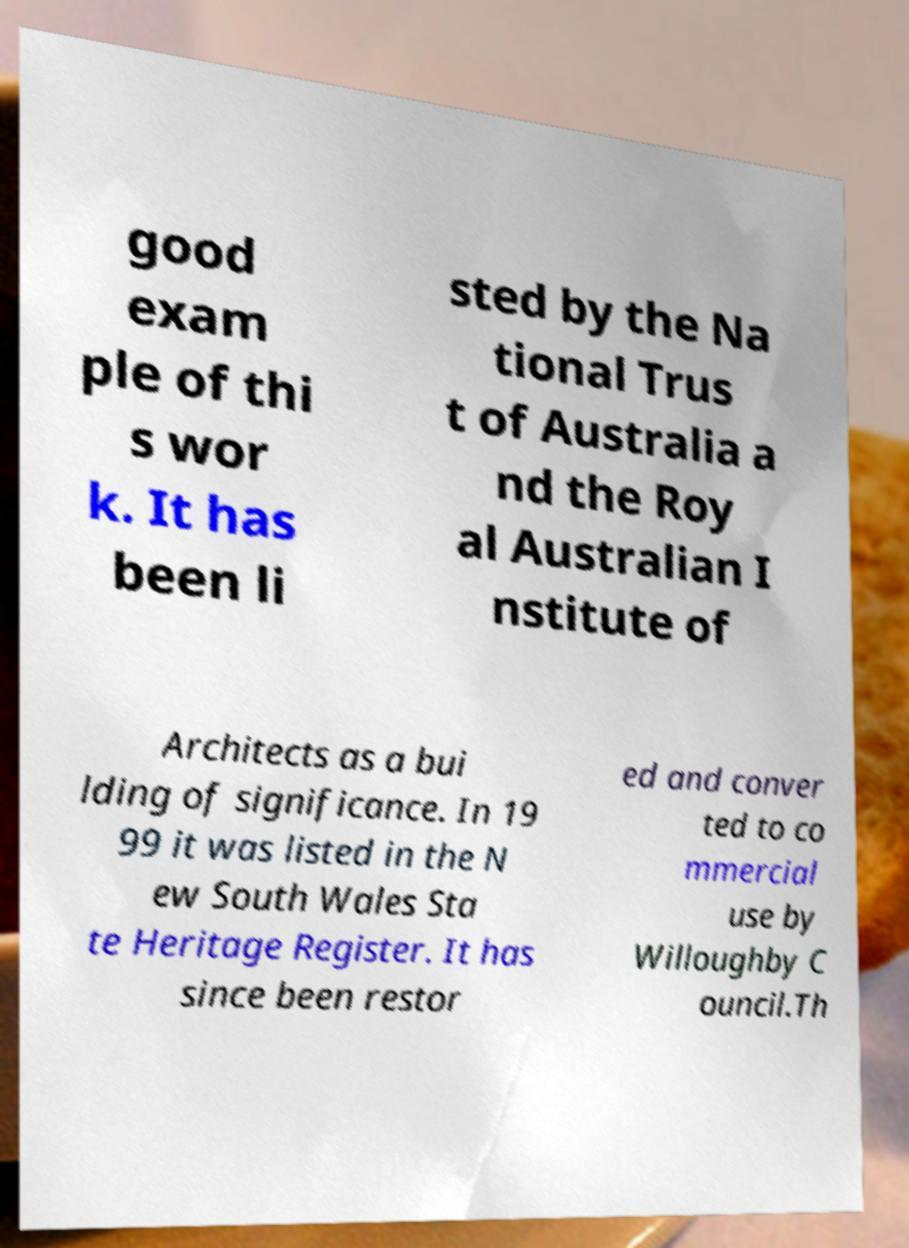Could you assist in decoding the text presented in this image and type it out clearly? good exam ple of thi s wor k. It has been li sted by the Na tional Trus t of Australia a nd the Roy al Australian I nstitute of Architects as a bui lding of significance. In 19 99 it was listed in the N ew South Wales Sta te Heritage Register. It has since been restor ed and conver ted to co mmercial use by Willoughby C ouncil.Th 